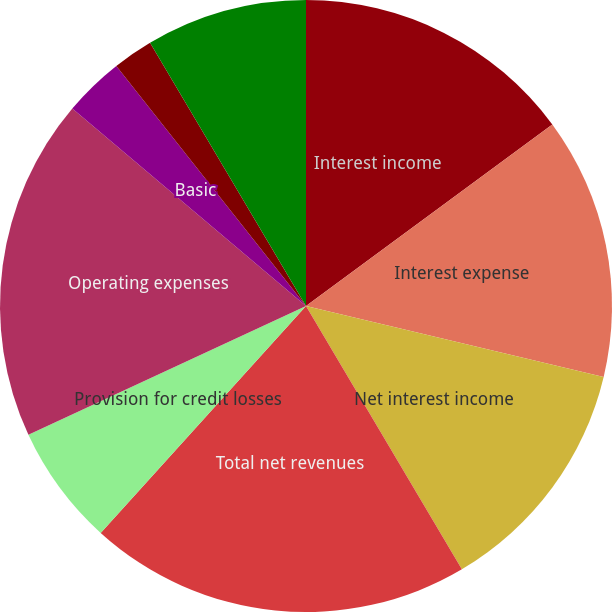<chart> <loc_0><loc_0><loc_500><loc_500><pie_chart><fcel>Interest income<fcel>Interest expense<fcel>Net interest income<fcel>Total net revenues<fcel>Provision for credit losses<fcel>Operating expenses<fcel>Basic<fcel>Diluted<fcel>Dividends declared per common<fcel>Basic shares<nl><fcel>14.89%<fcel>13.83%<fcel>12.77%<fcel>20.21%<fcel>6.38%<fcel>18.08%<fcel>3.19%<fcel>2.13%<fcel>0.0%<fcel>8.51%<nl></chart> 